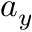<formula> <loc_0><loc_0><loc_500><loc_500>a _ { y }</formula> 